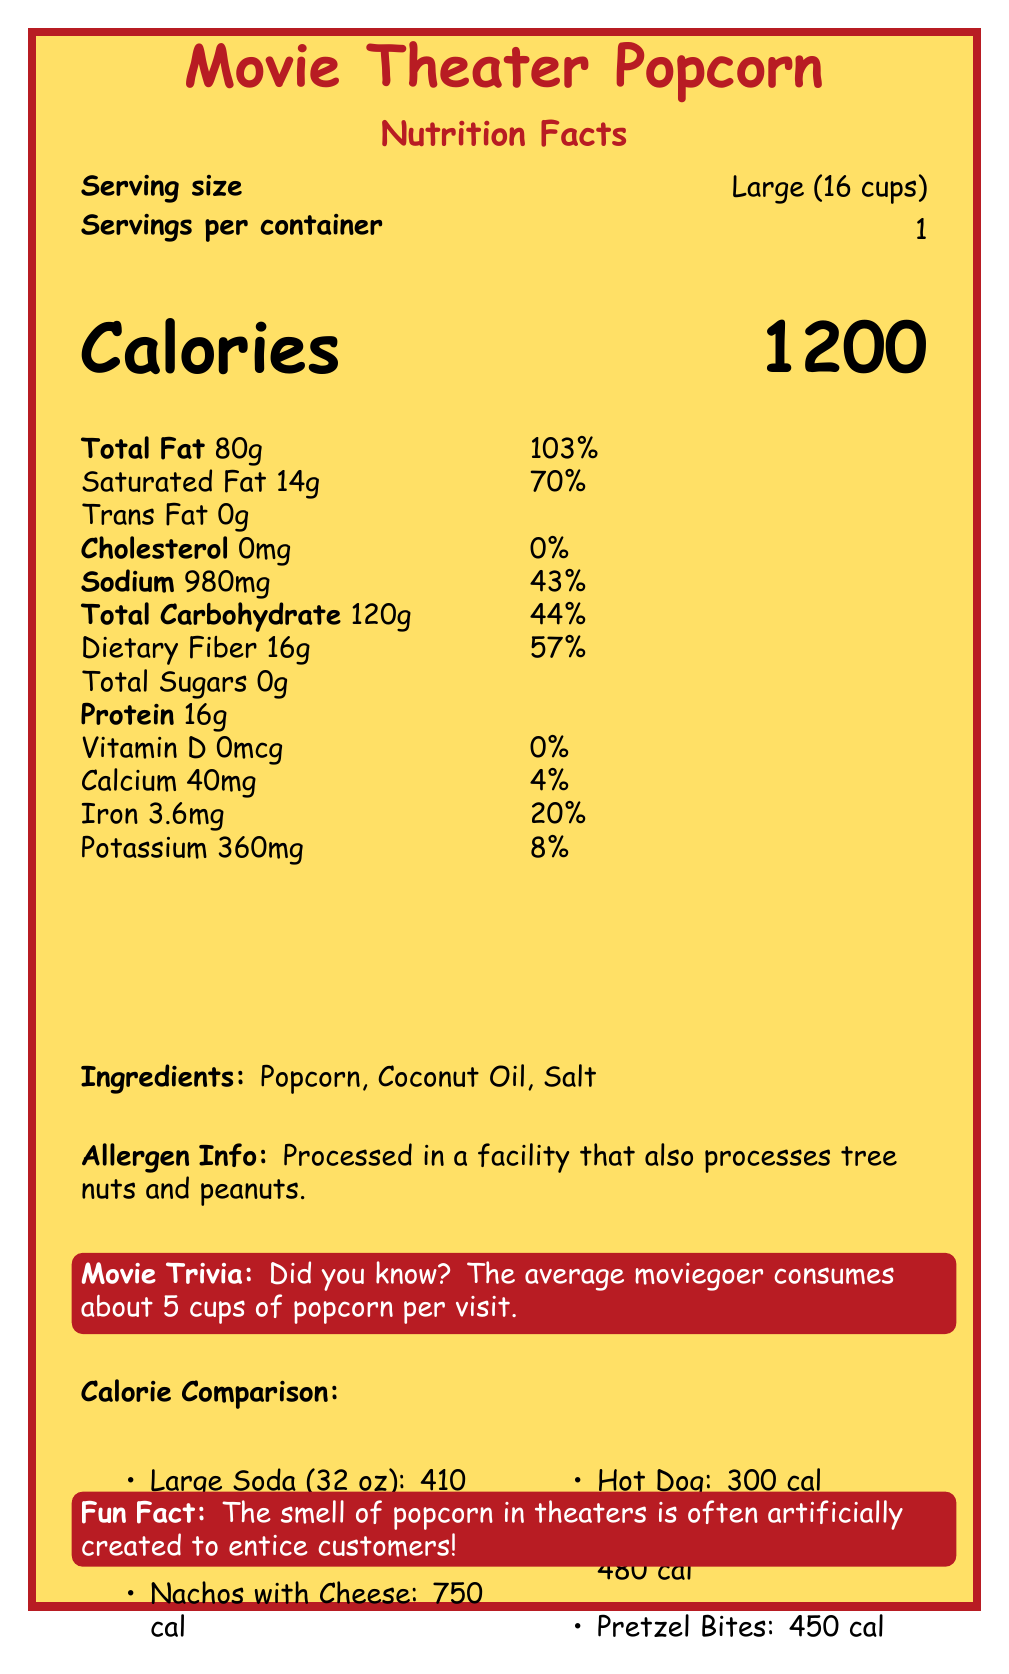what is the serving size for the Movie Theater Popcorn? The document specifies that the serving size for the Movie Theater Popcorn is "Large (16 cups)".
Answer: Large (16 cups) how many calories are in a large serving of Movie Theater Popcorn? The document clearly mentions that a large serving of Movie Theater Popcorn contains 1200 calories.
Answer: 1200 calories what is the total fat content in a serving of Movie Theater Popcorn? The document lists that the total fat content in a serving size is 80 grams.
Answer: 80g what is the daily value percentage of saturated fat in a serving of Movie Theater Popcorn? According to the document, the daily value percentage of saturated fat is 70%.
Answer: 70% what allergens might be present in the popcorn? The allergen info in the document states that the popcorn is processed in a facility that also processes tree nuts and peanuts.
Answer: Tree nuts and peanuts what is the sodium content (amount and daily value percentage) in a serving of Movie Theater Popcorn? The sodium content per serving is 980 milligrams, and this is 43% of the daily value.
Answer: 980mg, 43% how much protein is in a serving of Movie Theater Popcorn? The document lists 16 grams of protein in a serving of Movie Theater Popcorn.
Answer: 16g list three ingredients in Movie Theater Popcorn. The ingredients listed in the document are Popcorn, Coconut Oil, and Salt.
Answer: Popcorn, Coconut Oil, Salt what is the calorie content of a large soda? A. 300 B. 410 C. 750 The calorie content of a large soda, as stated in the comparison section of the document, is 410 calories.
Answer: B. 410 which of the following snacks has the fewest calories? A. Large Soda (32 oz) B. Nachos with Cheese C. Hot Dog D. Candy (M&M's, 3.4 oz) The Hot Dog contains the fewest calories among these options with 300 calories, according to the document.
Answer: C. Hot Dog is the cholesterol content in Movie Theater Popcorn higher than 10mg? The cholesterol content in Movie Theater Popcorn is 0mg, which is not higher than 10mg.
Answer: No summarize the main nutritional information and additional insights provided in the document. The document provides comprehensive information on the nutritional content, including calories, fats, sodium, and other nutrients for a large serving of Movie Theater Popcorn. It also gives context with a calorie comparison of different snacks and includes some interesting trivia and historical insights about popcorn in movie theaters.
Answer: The document details the nutritional facts of Movie Theater Popcorn, highlighting a large serving size of 16 cups that contains 1200 calories with significant amounts of fat, sodium, carbohydrates, and protein. It also compares the calorie content of popular movie snacks like large soda, nachos, and hot dogs. Additionally, it includes a fun fact about the artificial smell of popcorn, trivia, and a brief history of movie popcorn during the Great Depression. what is the percentage of daily value for dietary fiber? The document states that a serving of Movie Theater Popcorn provides 57% of the daily value for dietary fiber.
Answer: 57% how many calories are in a serving of Candy (M&M's, 3.4 oz)? The calorie comparison section of the document lists the calorie content of Candy (M&M's, 3.4 oz) as 480.
Answer: 480 calories what kind of oil is used in Movie Theater Popcorn? The ingredients list in the document mentions Coconut Oil as one of the components of Movie Theater Popcorn.
Answer: Coconut Oil how long has popcorn been popular in theaters? The document states that popcorn became popular in theaters during the Great Depression because of its low cost.
Answer: Since the Great Depression what file format is used to create the latex document? The file format used to create the LaTeX document is not mentioned in the visual information provided in the document.
Answer: Cannot be determined 